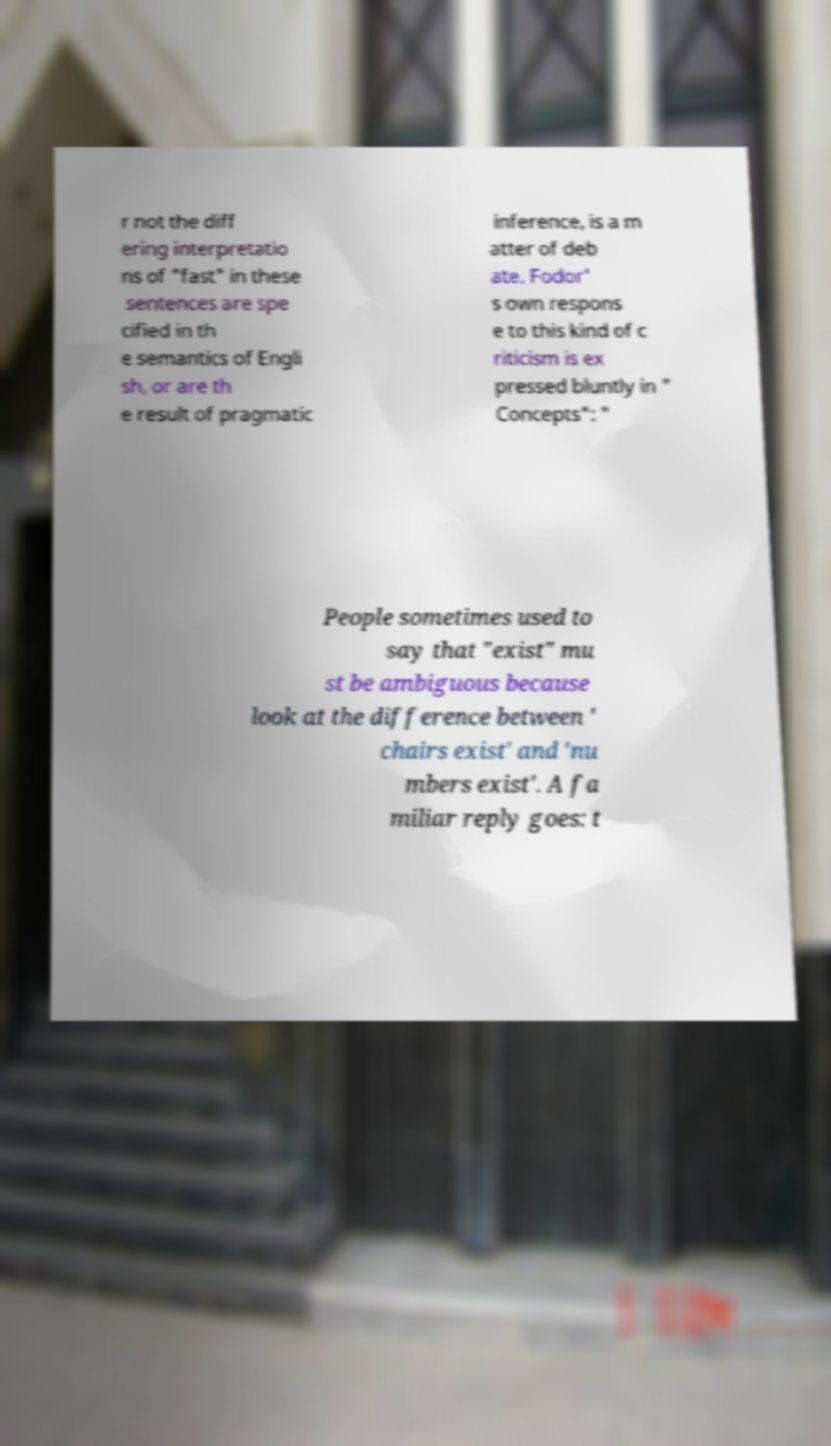For documentation purposes, I need the text within this image transcribed. Could you provide that? r not the diff ering interpretatio ns of "fast" in these sentences are spe cified in th e semantics of Engli sh, or are th e result of pragmatic inference, is a m atter of deb ate. Fodor' s own respons e to this kind of c riticism is ex pressed bluntly in " Concepts": " People sometimes used to say that "exist" mu st be ambiguous because look at the difference between ' chairs exist' and 'nu mbers exist'. A fa miliar reply goes: t 